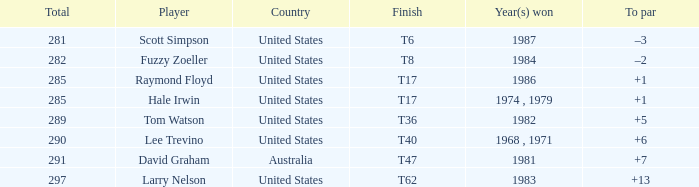What player has a total of 290 points? Lee Trevino. 